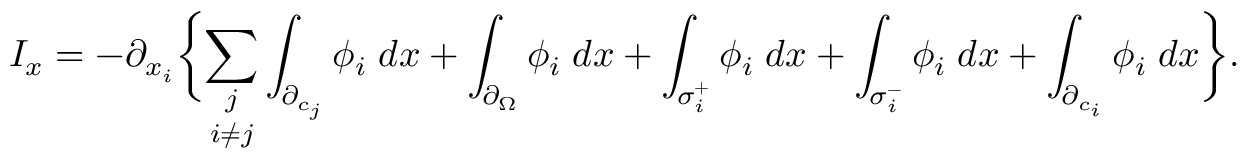<formula> <loc_0><loc_0><loc_500><loc_500>I _ { x } = - \partial _ { x _ { i } } \left \{ \underset { i \neq j } { \sum _ { j } } \int _ { \partial _ { c _ { j } } } \phi _ { i } \, d x + \int _ { \partial _ { \Omega } } \phi _ { i } \, d x + \int _ { \sigma _ { i } ^ { + } } \phi _ { i } \, d x + \int _ { \sigma _ { i } ^ { - } } \phi _ { i } \, d x + \int _ { \partial _ { c _ { i } } } \phi _ { i } \, d x \right \} .</formula> 